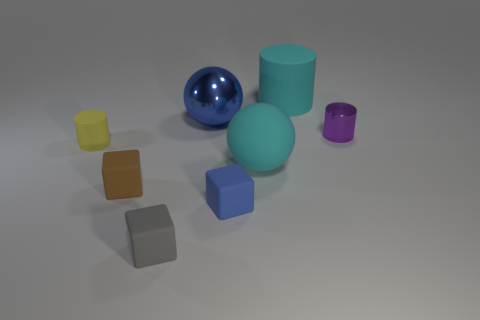Add 2 red objects. How many objects exist? 10 Subtract all cyan spheres. How many spheres are left? 1 Subtract all gray cubes. How many cubes are left? 2 Subtract all balls. How many objects are left? 6 Subtract 1 cubes. How many cubes are left? 2 Subtract all purple blocks. Subtract all cyan cylinders. How many blocks are left? 3 Subtract all brown cylinders. How many gray spheres are left? 0 Subtract all yellow matte things. Subtract all big metallic things. How many objects are left? 6 Add 4 tiny blue things. How many tiny blue things are left? 5 Add 5 tiny gray rubber objects. How many tiny gray rubber objects exist? 6 